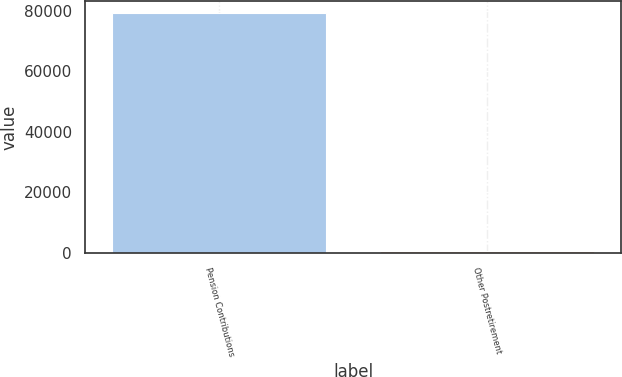Convert chart. <chart><loc_0><loc_0><loc_500><loc_500><bar_chart><fcel>Pension Contributions<fcel>Other Postretirement<nl><fcel>79386<fcel>525<nl></chart> 